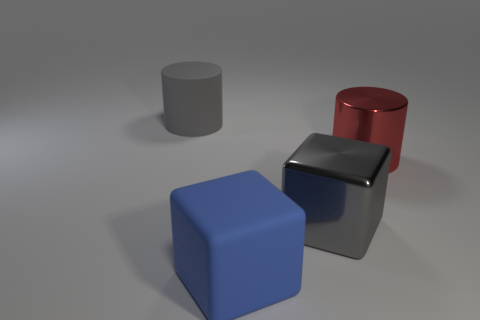What shape is the big thing that is made of the same material as the big gray block?
Your answer should be very brief. Cylinder. There is a thing that is the same material as the gray cube; what is its size?
Keep it short and to the point. Large. The large object that is in front of the big red metal cylinder and left of the gray block has what shape?
Make the answer very short. Cube. How big is the thing that is to the right of the large gray object that is in front of the gray rubber cylinder?
Your answer should be compact. Large. What number of other things are the same color as the metallic cube?
Your answer should be compact. 1. What is the gray cylinder made of?
Provide a short and direct response. Rubber. Is there a large shiny sphere?
Your response must be concise. No. Are there an equal number of gray metallic objects behind the gray metallic cube and large gray cylinders?
Offer a terse response. No. Is there anything else that is made of the same material as the red cylinder?
Your answer should be compact. Yes. How many large things are either red matte balls or blue things?
Offer a very short reply. 1. 